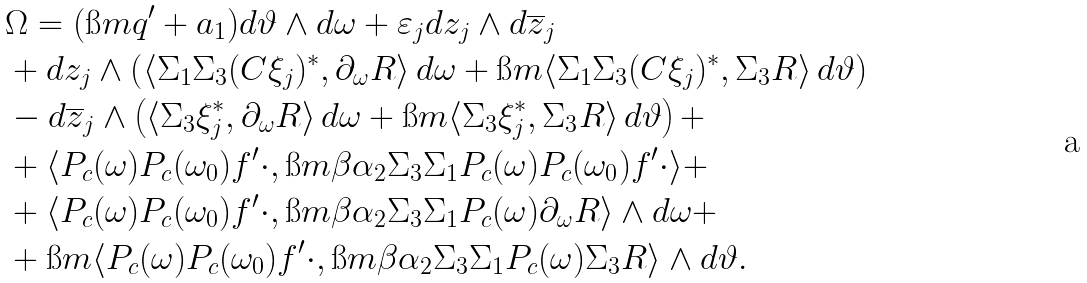<formula> <loc_0><loc_0><loc_500><loc_500>& \Omega = ( \i m q ^ { \prime } + a _ { 1 } ) d \vartheta \wedge d \omega + \varepsilon _ { j } d z _ { j } \wedge d \overline { z } _ { j } \\ & + d z _ { j } \wedge \left ( \langle \Sigma _ { 1 } \Sigma _ { 3 } ( C \xi _ { j } ) ^ { * } , \partial _ { \omega } R \rangle \, d \omega + \i m \langle \Sigma _ { 1 } \Sigma _ { 3 } ( C \xi _ { j } ) ^ { * } , \Sigma _ { 3 } R \rangle \, d \vartheta \right ) \\ & - d \overline { z } _ { j } \wedge \left ( \langle \Sigma _ { 3 } \xi _ { j } ^ { * } , \partial _ { \omega } R \rangle \, d \omega + \i m \langle \Sigma _ { 3 } \xi _ { j } ^ { * } , \Sigma _ { 3 } R \rangle \, d \vartheta \right ) + \\ & + \langle P _ { c } ( \omega ) P _ { c } ( \omega _ { 0 } ) f ^ { \prime } \cdot , \i m \beta \alpha _ { 2 } \Sigma _ { 3 } \Sigma _ { 1 } P _ { c } ( \omega ) P _ { c } ( \omega _ { 0 } ) f ^ { \prime } \cdot \rangle + \\ & + \langle P _ { c } ( \omega ) P _ { c } ( \omega _ { 0 } ) f ^ { \prime } \cdot , \i m \beta \alpha _ { 2 } \Sigma _ { 3 } \Sigma _ { 1 } P _ { c } ( \omega ) \partial _ { \omega } R \rangle \wedge d \omega + \\ & + \i m \langle P _ { c } ( \omega ) P _ { c } ( \omega _ { 0 } ) f ^ { \prime } \cdot , \i m \beta \alpha _ { 2 } \Sigma _ { 3 } \Sigma _ { 1 } P _ { c } ( \omega ) \Sigma _ { 3 } R \rangle \wedge d \vartheta .</formula> 